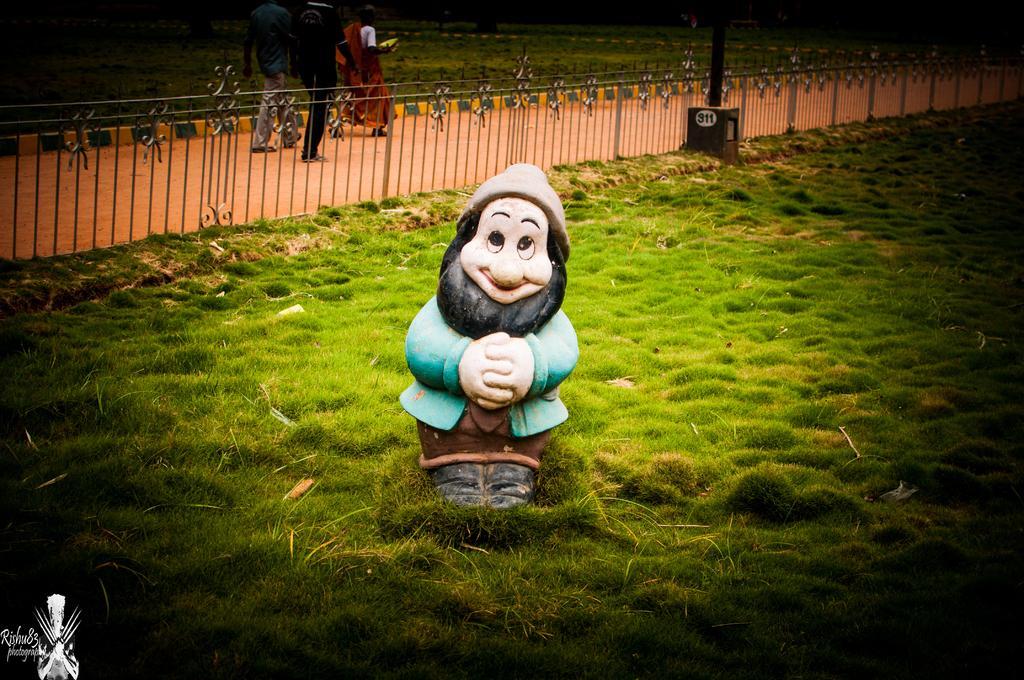In one or two sentences, can you explain what this image depicts? In this picture we can see a toy on the ground, beside this ground we can see a fence, pole and some people are walking on the road. 